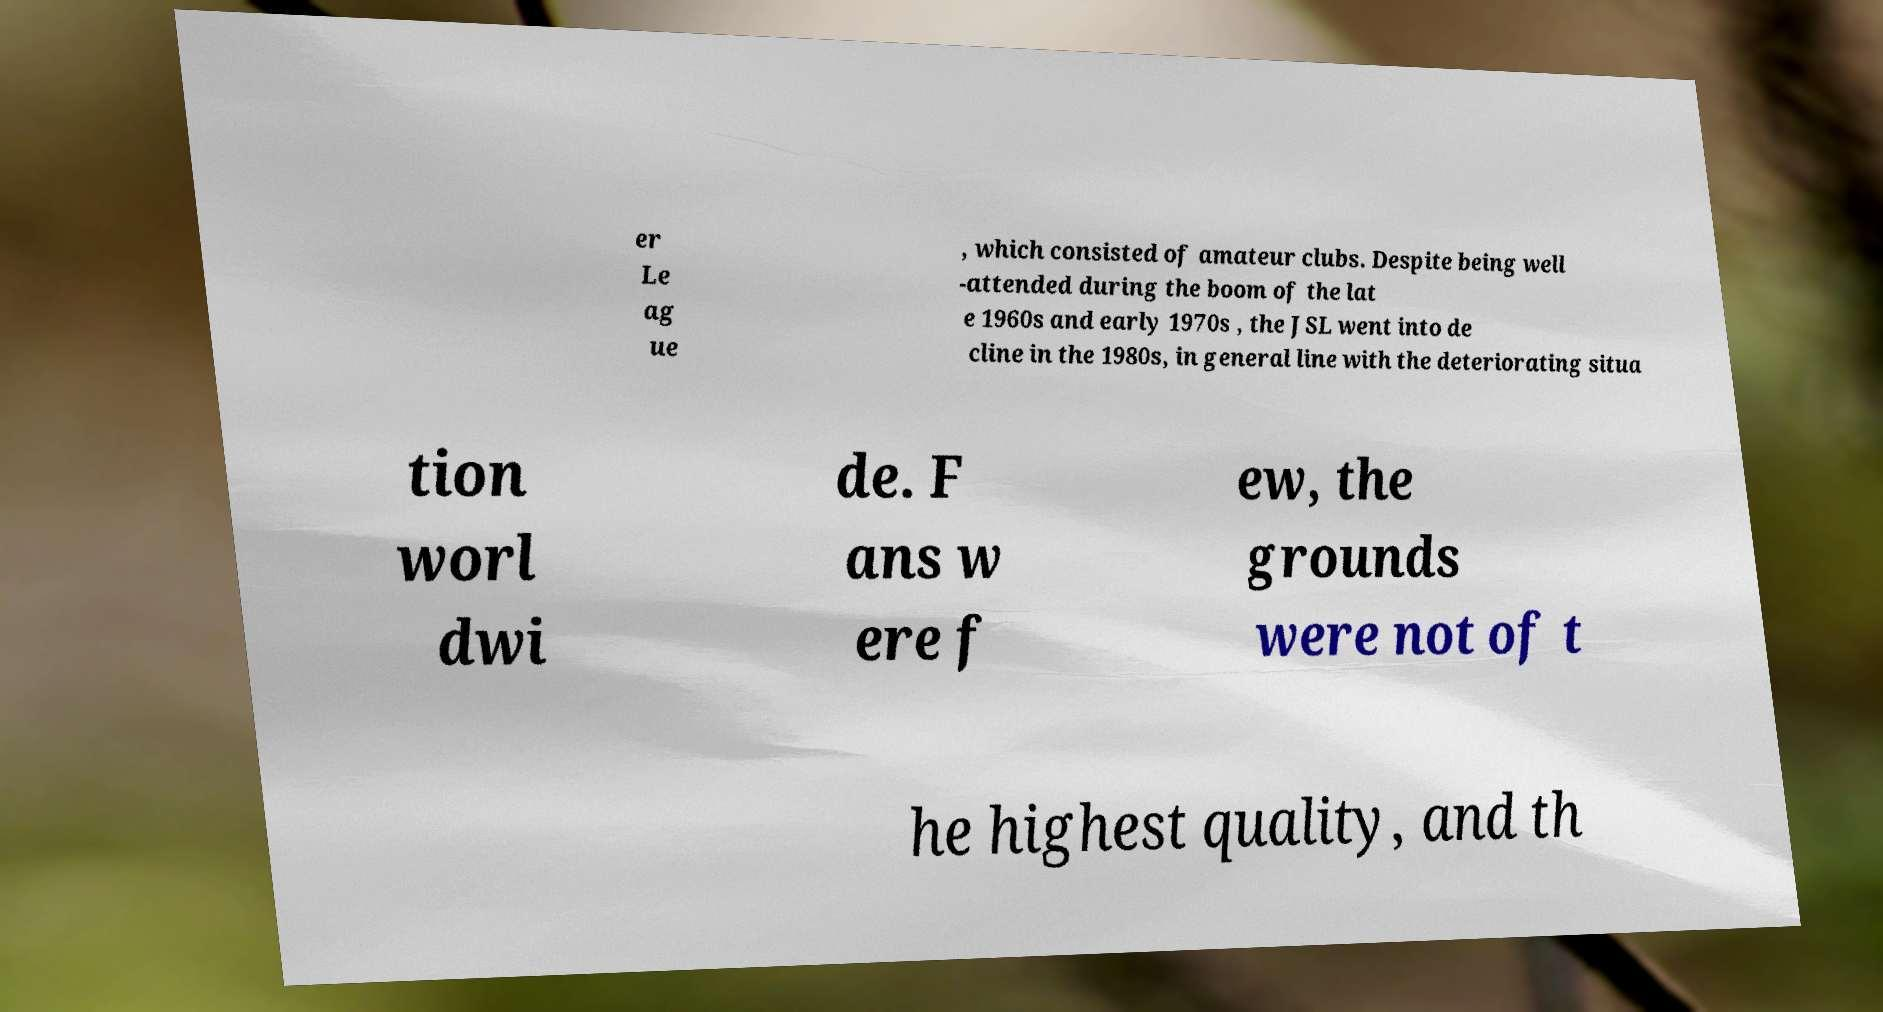What messages or text are displayed in this image? I need them in a readable, typed format. er Le ag ue , which consisted of amateur clubs. Despite being well -attended during the boom of the lat e 1960s and early 1970s , the JSL went into de cline in the 1980s, in general line with the deteriorating situa tion worl dwi de. F ans w ere f ew, the grounds were not of t he highest quality, and th 